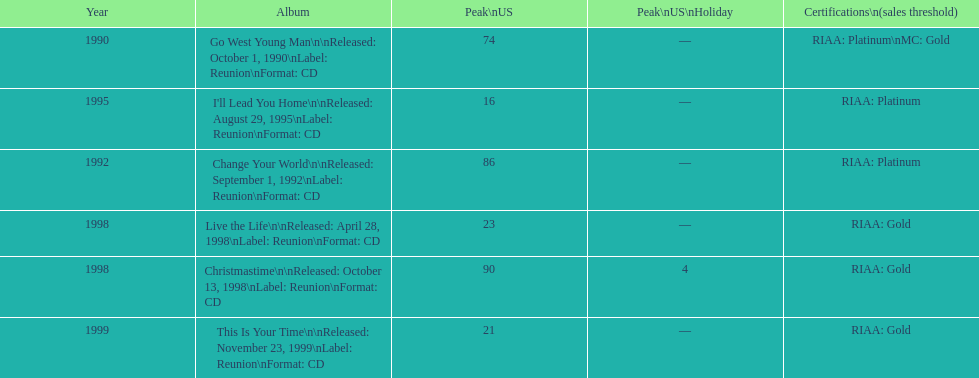How many album entries are there? 6. 